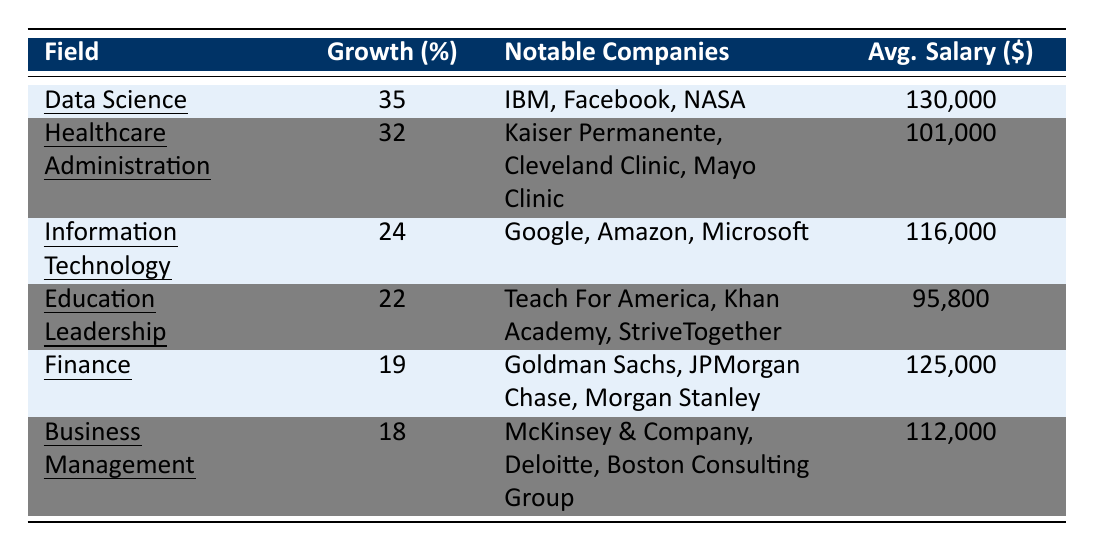What is the highest growth percentage for job demand in the table? The highest growth percentage in the table is found in the field of Data Science, which shows a growth of 35%.
Answer: 35% Which field has the lowest average salary according to the table? The field with the lowest average salary is Education Leadership, with an average salary of $95,800.
Answer: $95,800 List the notable companies associated with Healthcare Administration. The notable companies for Healthcare Administration are Kaiser Permanente, Cleveland Clinic, and Mayo Clinic, as listed in the table.
Answer: Kaiser Permanente, Cleveland Clinic, Mayo Clinic What is the average growth percentage of the fields listed in the table? To find the average growth percentage, add the growth percentages of all fields: (35 + 32 + 24 + 22 + 19 + 18) = 150. Then divide by the number of fields, which is 6. Thus, the average is 150/6 = 25%.
Answer: 25% True or False: Information Technology has a greater average salary than Business Management. The average salary for Information Technology is $116,000, while the average salary for Business Management is $112,000; therefore, the statement is true.
Answer: True Which field has a growth percentage closer to the average growth percentage? The average growth percentage is 25%. The fields with growth percentages closest to the average are Finance (19%) and Business Management (18%). The differences are 6% and 7% respectively. Finance is closer to 25%.
Answer: Finance What is the combined average salary of fields with more than 20% growth? The fields with more than 20% growth are Data Science (130,000), Healthcare Administration (101,000), and Information Technology (116,000). The combined average salary is calculated as (130,000 + 101,000 + 116,000) / 3 = 115,667.
Answer: $115,667 What is the difference in growth percentage between Data Science and Finance? The growth percentage for Data Science is 35%, while for Finance it is 19%. Therefore, the difference is 35% - 19% = 16%.
Answer: 16% Which notable company is associated with Finance? The notable companies associated with Finance include Goldman Sachs, JPMorgan Chase, and Morgan Stanley, as stated in the table.
Answer: Goldman Sachs, JPMorgan Chase, Morgan Stanley How many fields have an average salary above $100,000? The fields with an average salary above $100,000 are Data Science ($130,000), Finance ($125,000), and Healthcare Administration ($101,000), totaling three fields.
Answer: 3 